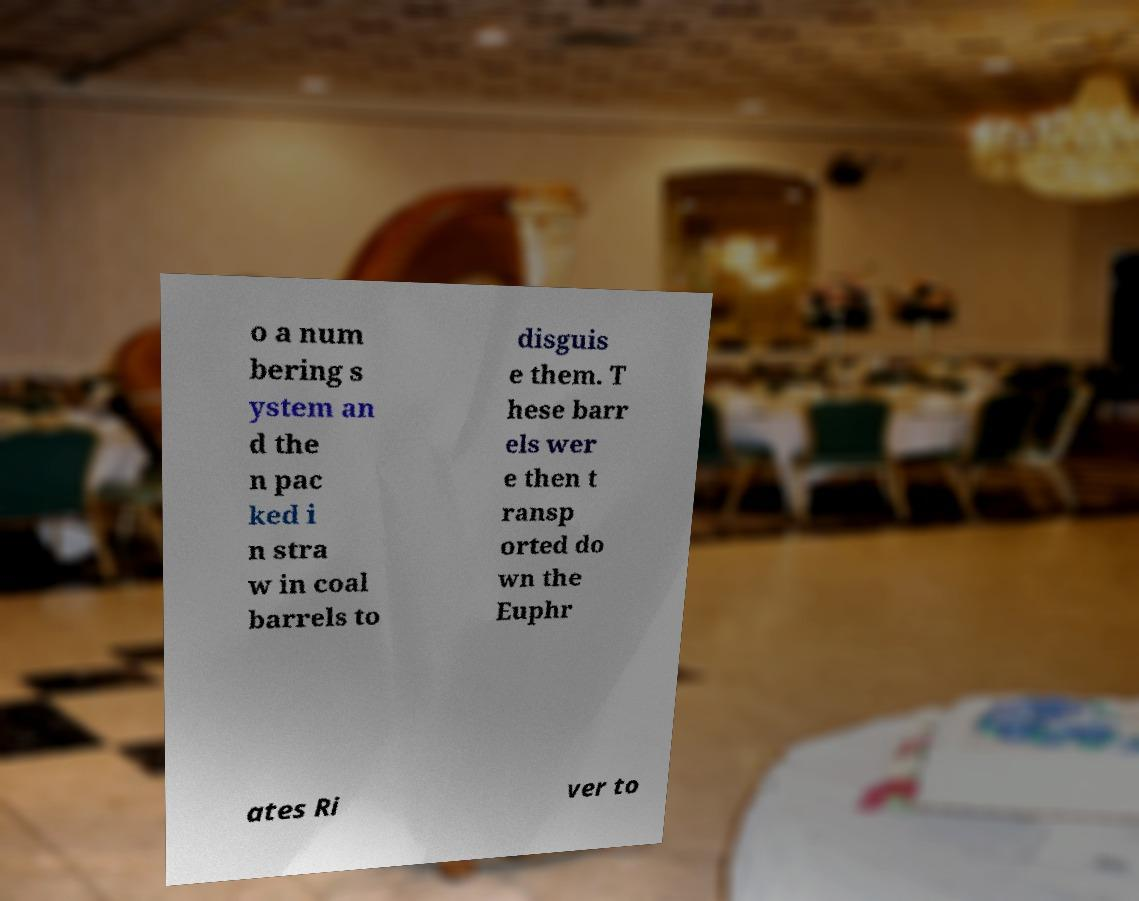Please identify and transcribe the text found in this image. o a num bering s ystem an d the n pac ked i n stra w in coal barrels to disguis e them. T hese barr els wer e then t ransp orted do wn the Euphr ates Ri ver to 